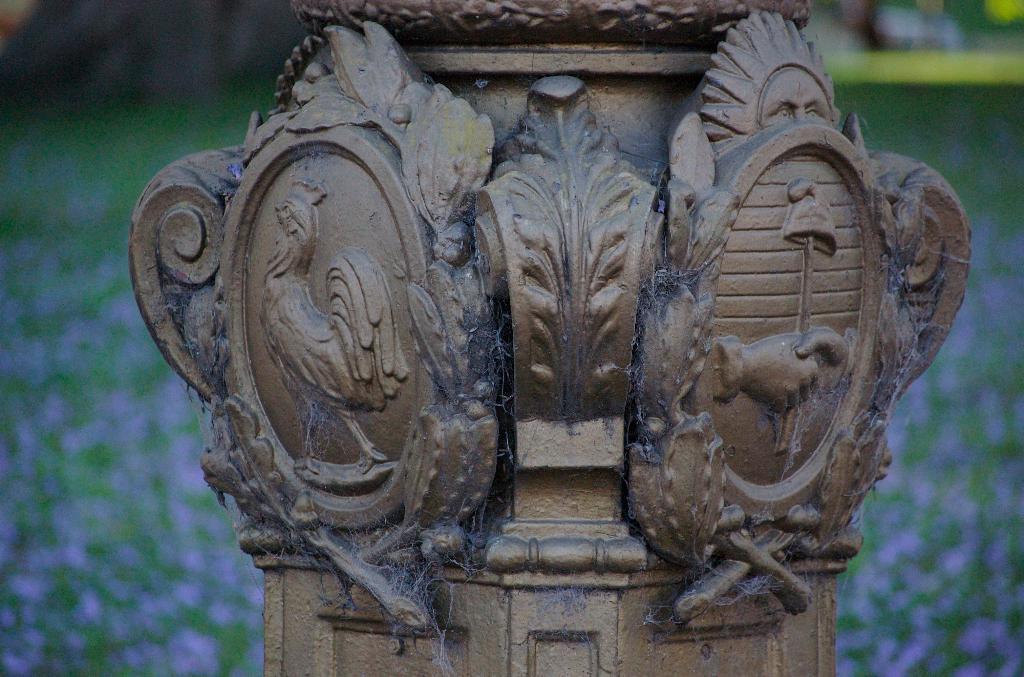Could you give a brief overview of what you see in this image? In the foreground of this image, there is a sculpture on a pillar and the background image is blur. 